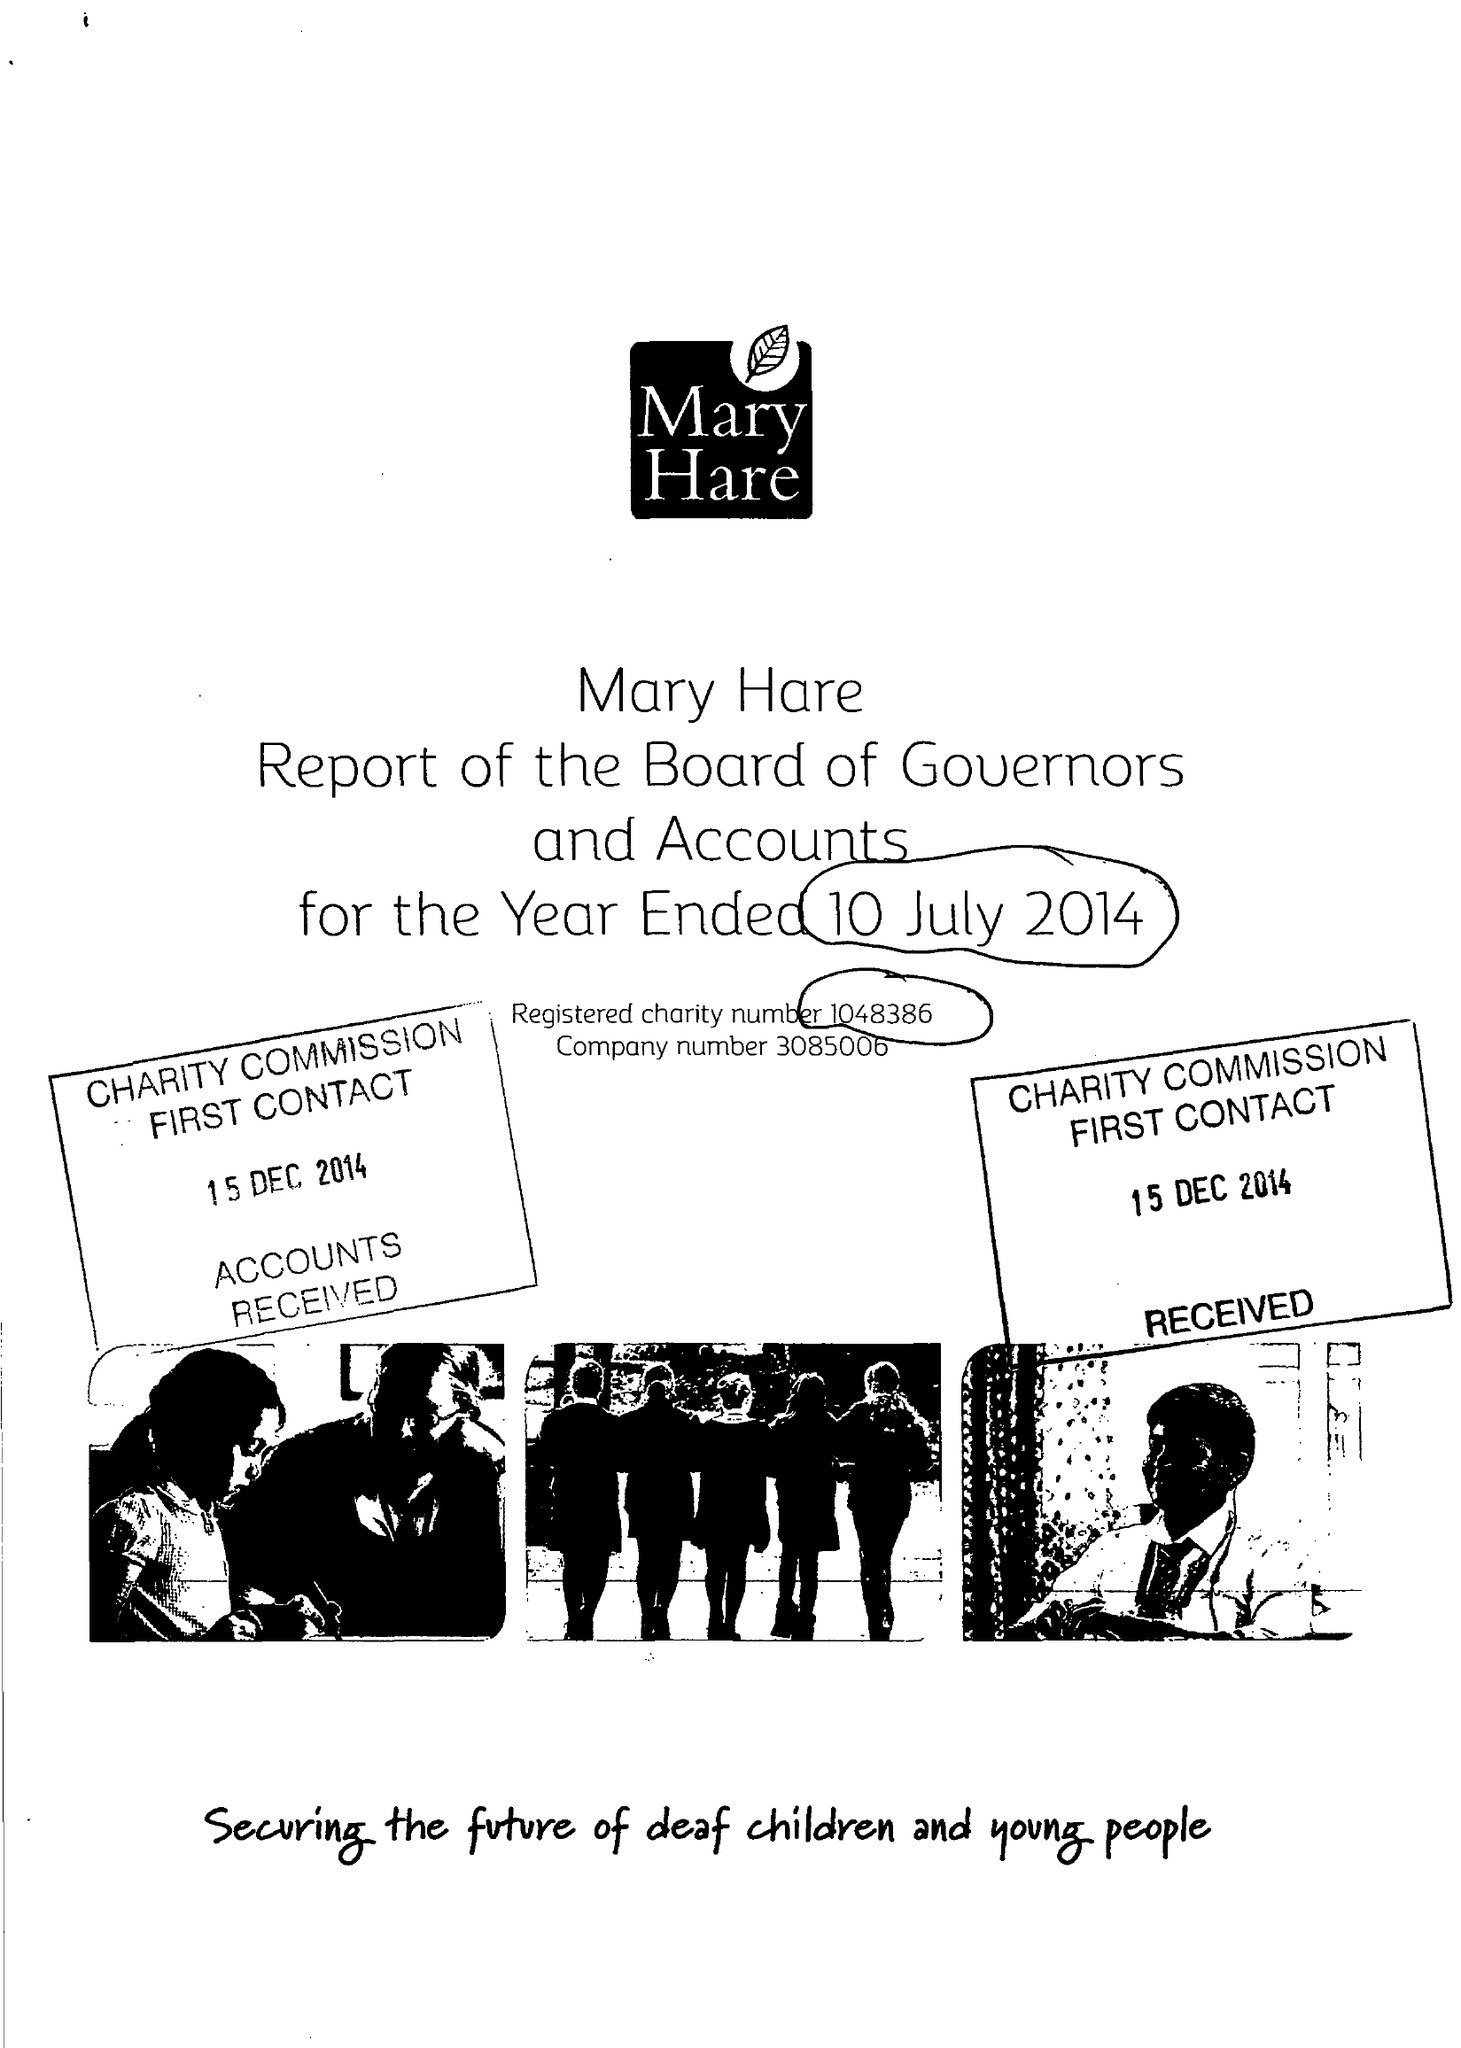What is the value for the address__street_line?
Answer the question using a single word or phrase. NEWBURY 